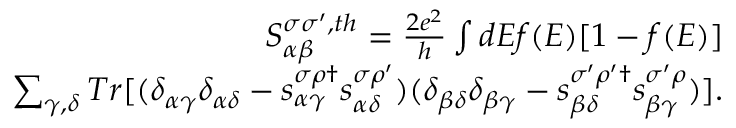<formula> <loc_0><loc_0><loc_500><loc_500>\begin{array} { r } { { S _ { \alpha \beta } ^ { \sigma \sigma ^ { \prime } , t h } } = \frac { 2 e ^ { 2 } } { h } \int d E f ( E ) [ 1 - f ( E ) ] } \\ { \sum _ { \gamma , \delta } T r [ ( \delta _ { \alpha \gamma } \delta _ { \alpha \delta } - s _ { \alpha \gamma } ^ { \sigma \rho \dagger } s _ { \alpha \delta } ^ { \sigma \rho ^ { \prime } } ) ( \delta _ { \beta \delta } \delta _ { \beta \gamma } - s _ { \beta \delta } ^ { \sigma ^ { \prime } \rho ^ { \prime } \dagger } s _ { \beta \gamma } ^ { \sigma ^ { \prime } \rho } ) ] . } \end{array}</formula> 